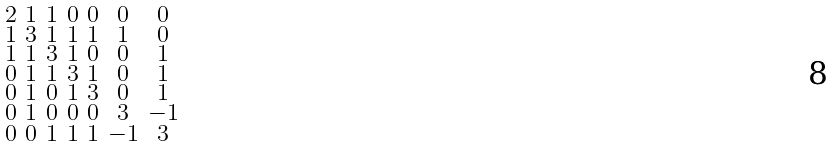<formula> <loc_0><loc_0><loc_500><loc_500>\begin{smallmatrix} 2 & 1 & 1 & 0 & 0 & 0 & 0 \\ 1 & 3 & 1 & 1 & 1 & 1 & 0 \\ 1 & 1 & 3 & 1 & 0 & 0 & 1 \\ 0 & 1 & 1 & 3 & 1 & 0 & 1 \\ 0 & 1 & 0 & 1 & 3 & 0 & 1 \\ 0 & 1 & 0 & 0 & 0 & 3 & - 1 \\ 0 & 0 & 1 & 1 & 1 & - 1 & 3 \end{smallmatrix}</formula> 